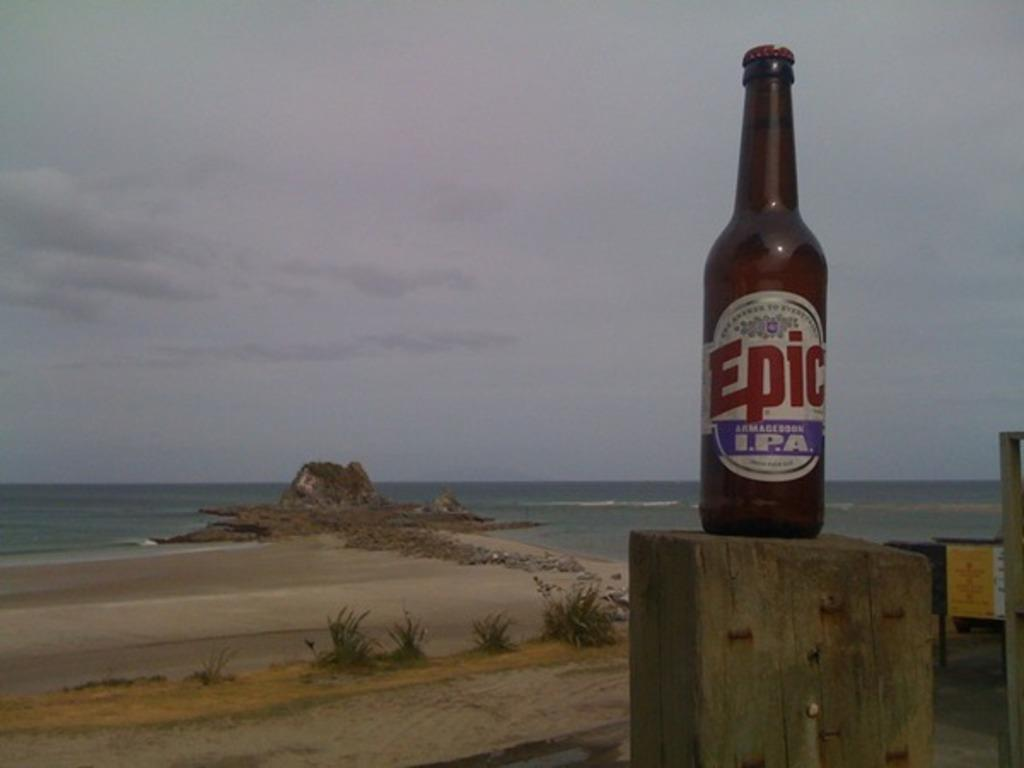Provide a one-sentence caption for the provided image. With the ocean and beach in the back ground a wooden post has a bottle of Epic brand beer sitting on it. 